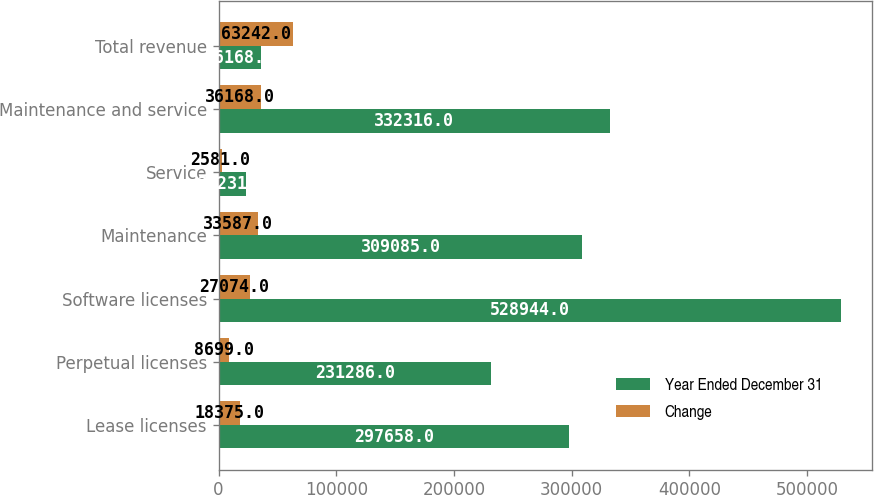Convert chart. <chart><loc_0><loc_0><loc_500><loc_500><stacked_bar_chart><ecel><fcel>Lease licenses<fcel>Perpetual licenses<fcel>Software licenses<fcel>Maintenance<fcel>Service<fcel>Maintenance and service<fcel>Total revenue<nl><fcel>Year Ended December 31<fcel>297658<fcel>231286<fcel>528944<fcel>309085<fcel>23231<fcel>332316<fcel>36168<nl><fcel>Change<fcel>18375<fcel>8699<fcel>27074<fcel>33587<fcel>2581<fcel>36168<fcel>63242<nl></chart> 